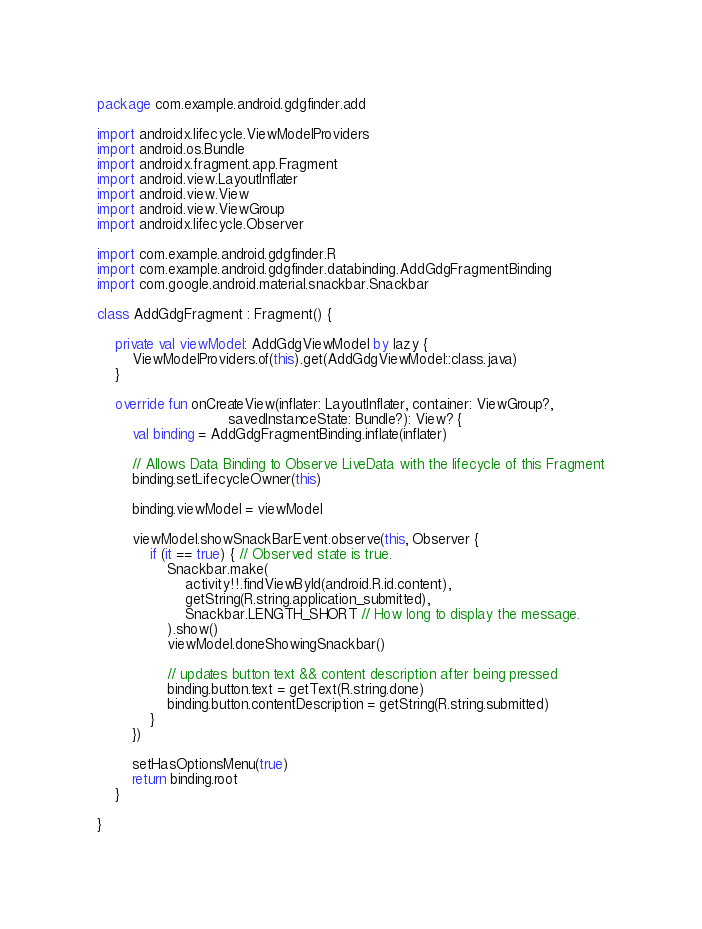<code> <loc_0><loc_0><loc_500><loc_500><_Kotlin_>package com.example.android.gdgfinder.add

import androidx.lifecycle.ViewModelProviders
import android.os.Bundle
import androidx.fragment.app.Fragment
import android.view.LayoutInflater
import android.view.View
import android.view.ViewGroup
import androidx.lifecycle.Observer

import com.example.android.gdgfinder.R
import com.example.android.gdgfinder.databinding.AddGdgFragmentBinding
import com.google.android.material.snackbar.Snackbar

class AddGdgFragment : Fragment() {

    private val viewModel: AddGdgViewModel by lazy {
        ViewModelProviders.of(this).get(AddGdgViewModel::class.java)
    }

    override fun onCreateView(inflater: LayoutInflater, container: ViewGroup?,
                              savedInstanceState: Bundle?): View? {
        val binding = AddGdgFragmentBinding.inflate(inflater)

        // Allows Data Binding to Observe LiveData with the lifecycle of this Fragment
        binding.setLifecycleOwner(this)

        binding.viewModel = viewModel

        viewModel.showSnackBarEvent.observe(this, Observer {
            if (it == true) { // Observed state is true.
                Snackbar.make(
                    activity!!.findViewById(android.R.id.content),
                    getString(R.string.application_submitted),
                    Snackbar.LENGTH_SHORT // How long to display the message.
                ).show()
                viewModel.doneShowingSnackbar()

                // updates button text && content description after being pressed
                binding.button.text = getText(R.string.done)
                binding.button.contentDescription = getString(R.string.submitted)
            }
        })

        setHasOptionsMenu(true)
        return binding.root
    }

}
</code> 